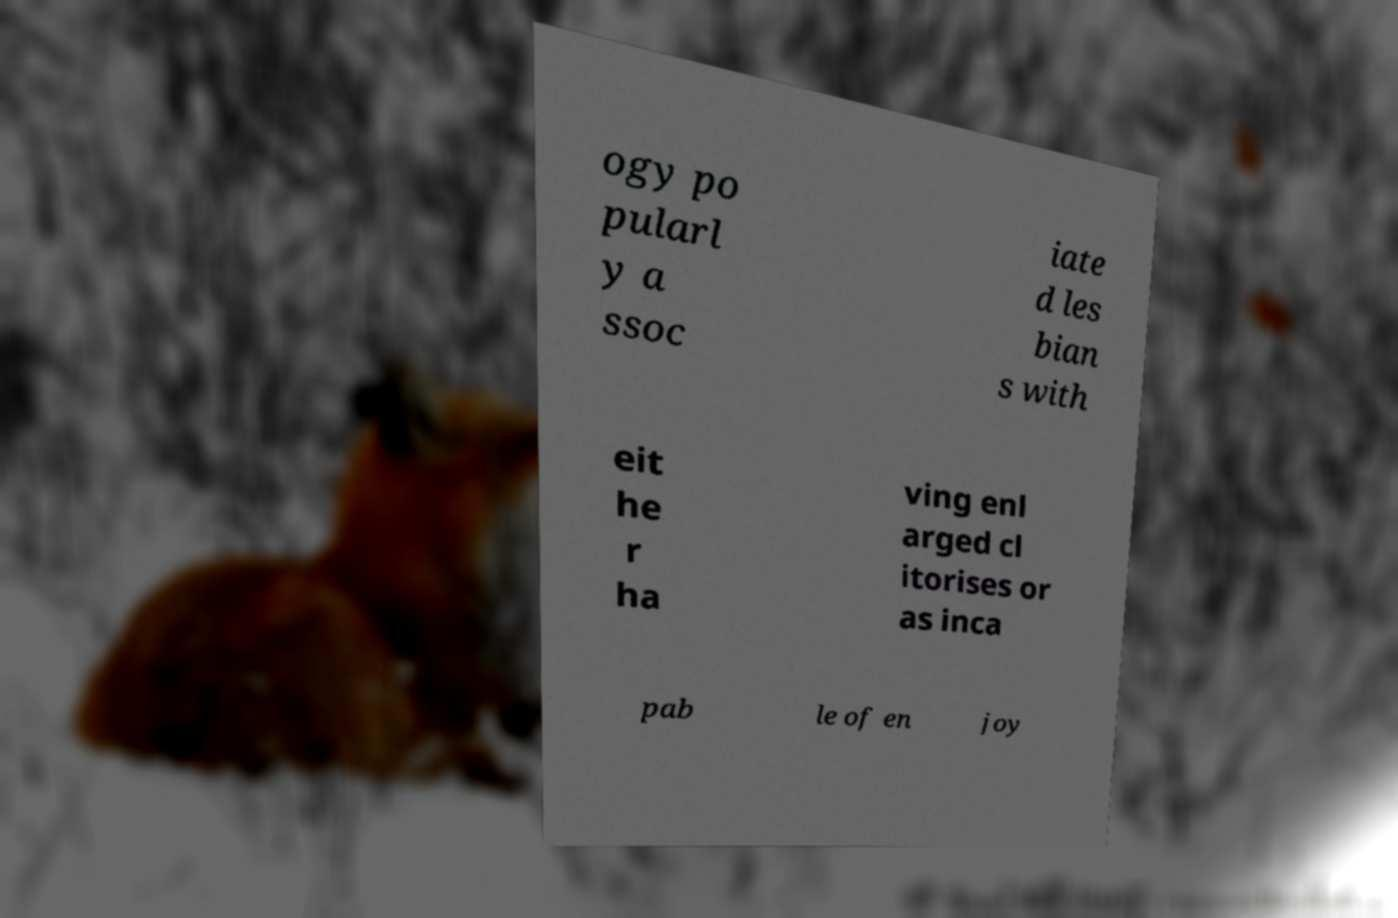For documentation purposes, I need the text within this image transcribed. Could you provide that? ogy po pularl y a ssoc iate d les bian s with eit he r ha ving enl arged cl itorises or as inca pab le of en joy 